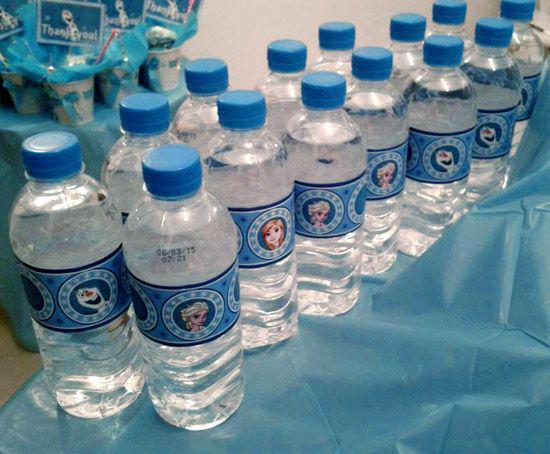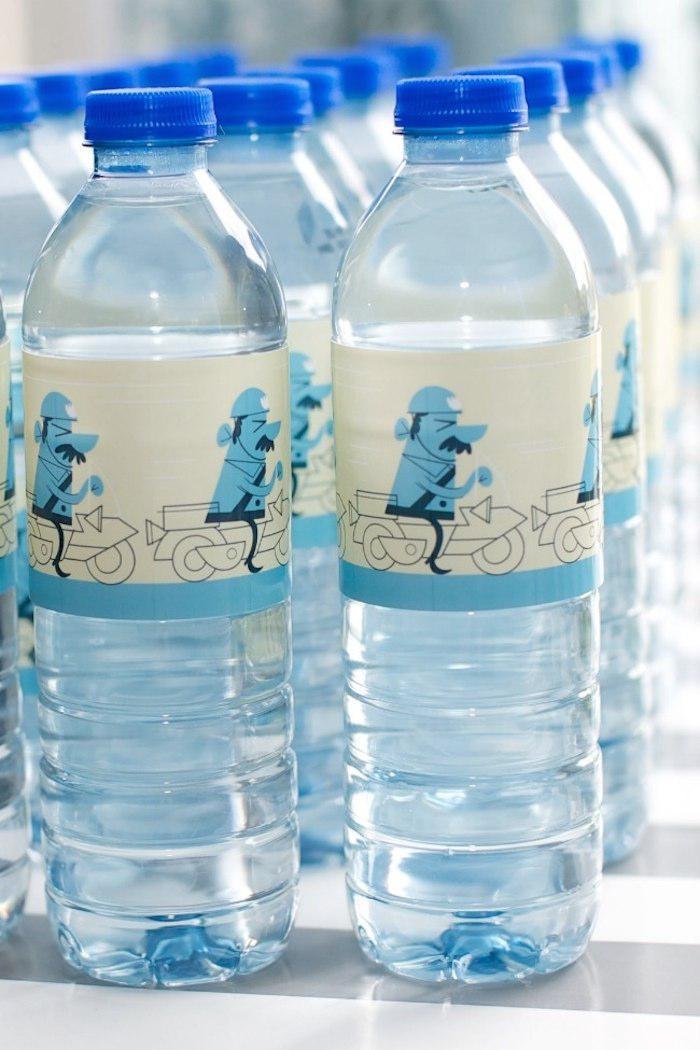The first image is the image on the left, the second image is the image on the right. Given the left and right images, does the statement "An image shows bottles with orange lids." hold true? Answer yes or no. No. 